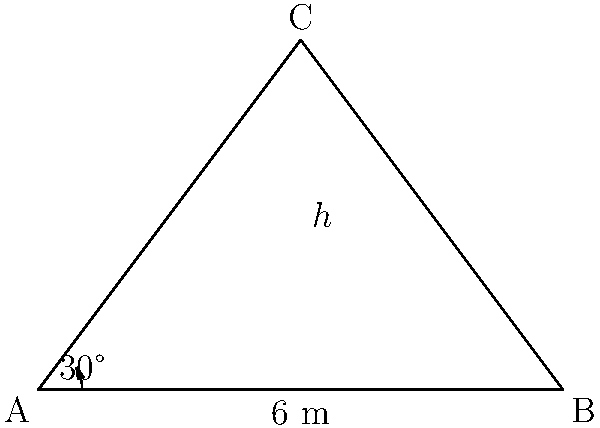In a high-speed car chase scene, you need to set up a camera to capture a stunt where a car jumps over a ramp. The ramp forms a right-angled triangle with a base of 6 meters and a height of 4 meters. To get the best shot, you need to position the camera at point A, forming a 30° angle with the ground. What is the optimal camera angle (θ) from the horizontal to the top of the ramp (point C) to capture the entire stunt? Let's approach this step-by-step:

1) First, we need to find the angle of elevation from point A to point C. We can do this by using the trigonometric ratios in the right-angled triangle ABC.

2) In triangle ABC:
   - The base (AB) is 6 meters
   - The height (BC) is 4 meters

3) We can find the angle BAC using the tangent function:

   $$\tan(BAC) = \frac{opposite}{adjacent} = \frac{4}{6} = \frac{2}{3}$$

4) To find the angle BAC:

   $$BAC = \arctan(\frac{2}{3}) \approx 33.69°$$

5) Now, we know that the camera is positioned at a 30° angle from the ground. To find the optimal camera angle θ, we need to subtract this from the angle BAC:

   $$θ = BAC - 30°$$
   $$θ = 33.69° - 30° \approx 3.69°$$

6) Therefore, the optimal camera angle from the horizontal to capture the entire stunt is approximately 3.69°.
Answer: 3.69° 